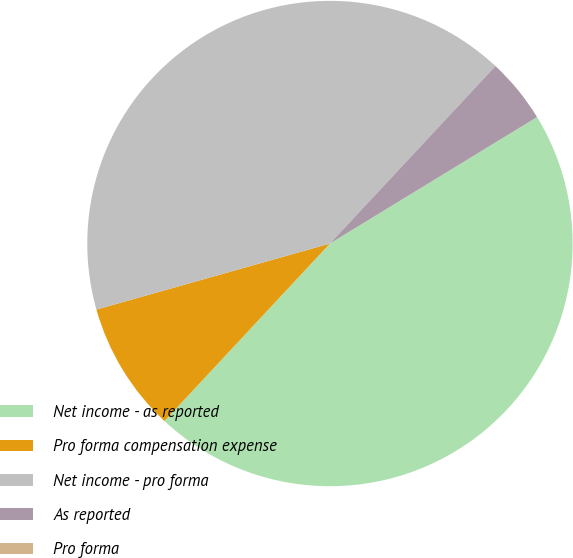<chart> <loc_0><loc_0><loc_500><loc_500><pie_chart><fcel>Net income - as reported<fcel>Pro forma compensation expense<fcel>Net income - pro forma<fcel>As reported<fcel>Pro forma<nl><fcel>45.67%<fcel>8.67%<fcel>41.33%<fcel>4.33%<fcel>0.0%<nl></chart> 